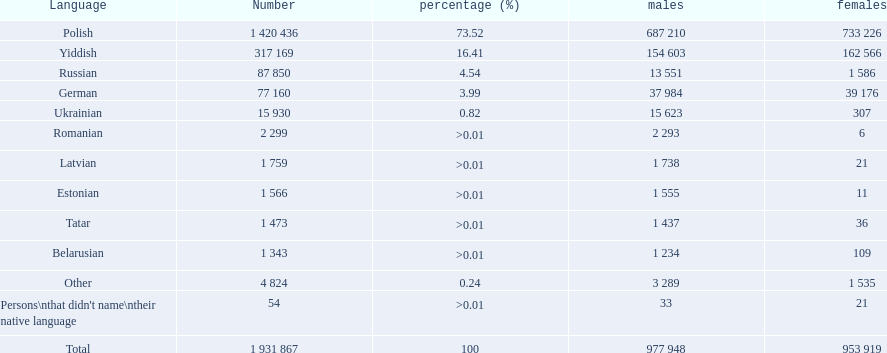What languages are spoken in the warsaw governorate? Polish, Yiddish, Russian, German, Ukrainian, Romanian, Latvian, Estonian, Tatar, Belarusian. Which are the top five languages? Polish, Yiddish, Russian, German, Ukrainian. Of those which is the 2nd most frequently spoken? Yiddish. 